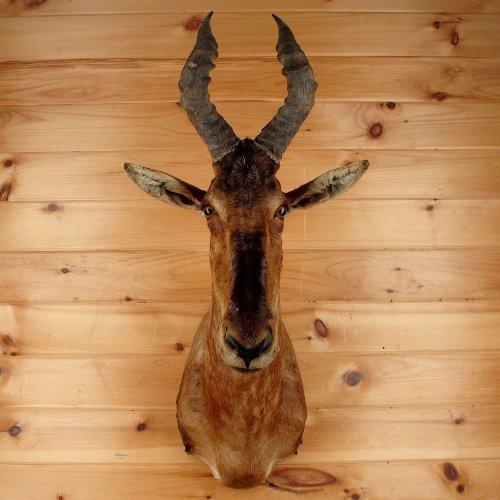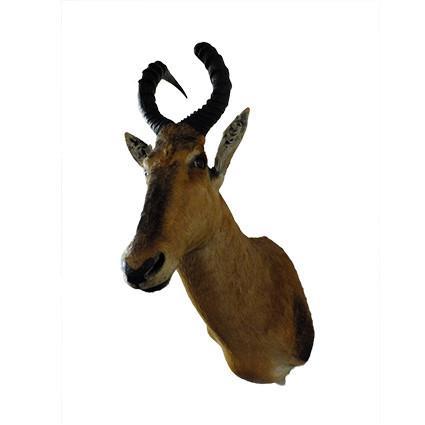The first image is the image on the left, the second image is the image on the right. Analyze the images presented: Is the assertion "At least one of the animals is mounted on a grey marblized wall." valid? Answer yes or no. No. The first image is the image on the left, the second image is the image on the right. For the images displayed, is the sentence "The taxidermied horned head on the left faces head-on, and the one on the right is angled leftward." factually correct? Answer yes or no. Yes. 